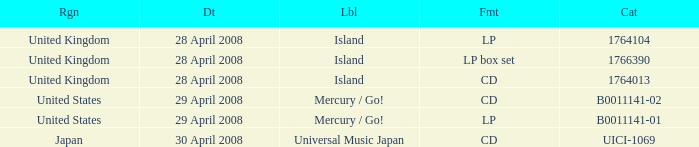What is the Label of the UICI-1069 Catalog? Universal Music Japan. 